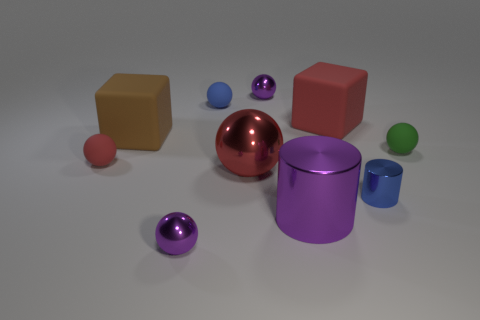What number of other things are there of the same material as the brown cube
Your answer should be compact. 4. How many rubber objects are blue cylinders or brown blocks?
Ensure brevity in your answer.  1. Are there fewer large matte spheres than brown blocks?
Provide a short and direct response. Yes. There is a green object; is it the same size as the red sphere to the left of the large brown thing?
Make the answer very short. Yes. Is there anything else that is the same shape as the brown object?
Your response must be concise. Yes. How big is the brown object?
Keep it short and to the point. Large. Are there fewer small blue rubber things that are behind the small green ball than large red rubber things?
Your answer should be compact. No. Do the brown matte cube and the green ball have the same size?
Give a very brief answer. No. Is there anything else that has the same size as the green matte object?
Keep it short and to the point. Yes. There is another block that is the same material as the red cube; what color is it?
Give a very brief answer. Brown. 